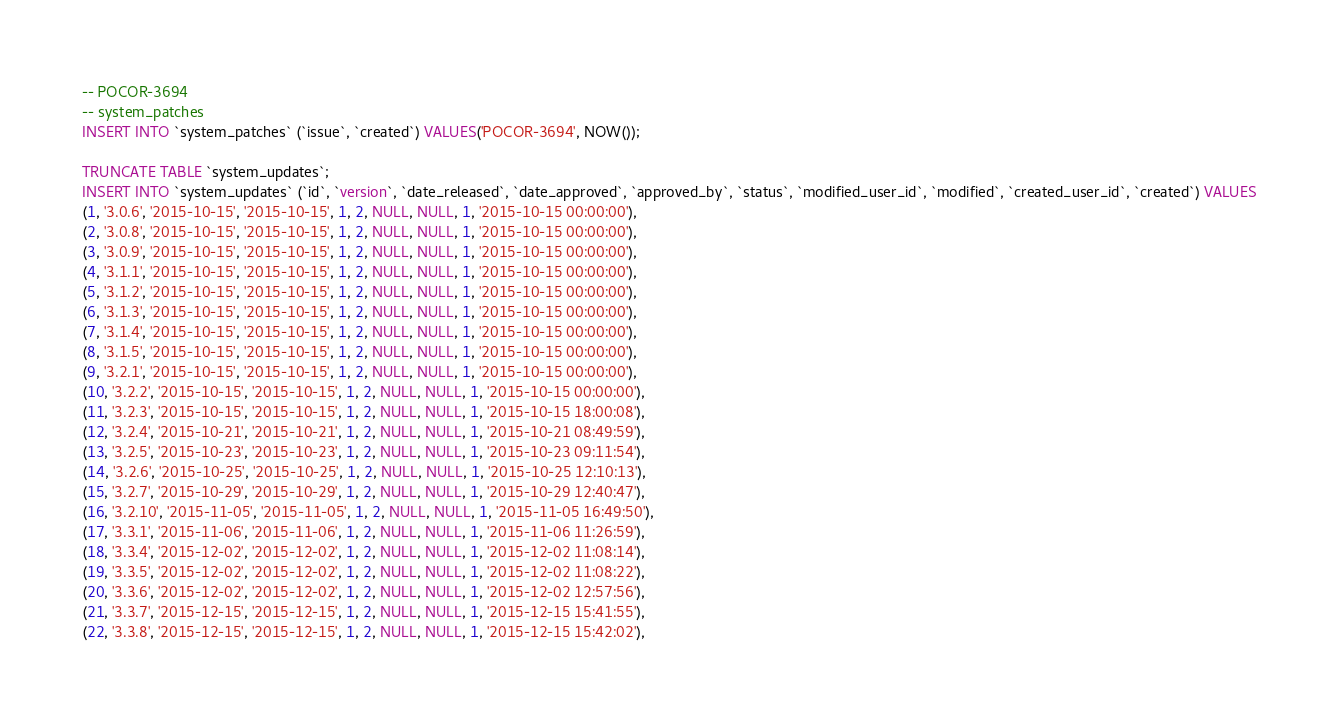<code> <loc_0><loc_0><loc_500><loc_500><_SQL_>-- POCOR-3694
-- system_patches
INSERT INTO `system_patches` (`issue`, `created`) VALUES('POCOR-3694', NOW());

TRUNCATE TABLE `system_updates`;
INSERT INTO `system_updates` (`id`, `version`, `date_released`, `date_approved`, `approved_by`, `status`, `modified_user_id`, `modified`, `created_user_id`, `created`) VALUES
(1, '3.0.6', '2015-10-15', '2015-10-15', 1, 2, NULL, NULL, 1, '2015-10-15 00:00:00'),
(2, '3.0.8', '2015-10-15', '2015-10-15', 1, 2, NULL, NULL, 1, '2015-10-15 00:00:00'),
(3, '3.0.9', '2015-10-15', '2015-10-15', 1, 2, NULL, NULL, 1, '2015-10-15 00:00:00'),
(4, '3.1.1', '2015-10-15', '2015-10-15', 1, 2, NULL, NULL, 1, '2015-10-15 00:00:00'),
(5, '3.1.2', '2015-10-15', '2015-10-15', 1, 2, NULL, NULL, 1, '2015-10-15 00:00:00'),
(6, '3.1.3', '2015-10-15', '2015-10-15', 1, 2, NULL, NULL, 1, '2015-10-15 00:00:00'),
(7, '3.1.4', '2015-10-15', '2015-10-15', 1, 2, NULL, NULL, 1, '2015-10-15 00:00:00'),
(8, '3.1.5', '2015-10-15', '2015-10-15', 1, 2, NULL, NULL, 1, '2015-10-15 00:00:00'),
(9, '3.2.1', '2015-10-15', '2015-10-15', 1, 2, NULL, NULL, 1, '2015-10-15 00:00:00'),
(10, '3.2.2', '2015-10-15', '2015-10-15', 1, 2, NULL, NULL, 1, '2015-10-15 00:00:00'),
(11, '3.2.3', '2015-10-15', '2015-10-15', 1, 2, NULL, NULL, 1, '2015-10-15 18:00:08'),
(12, '3.2.4', '2015-10-21', '2015-10-21', 1, 2, NULL, NULL, 1, '2015-10-21 08:49:59'),
(13, '3.2.5', '2015-10-23', '2015-10-23', 1, 2, NULL, NULL, 1, '2015-10-23 09:11:54'),
(14, '3.2.6', '2015-10-25', '2015-10-25', 1, 2, NULL, NULL, 1, '2015-10-25 12:10:13'),
(15, '3.2.7', '2015-10-29', '2015-10-29', 1, 2, NULL, NULL, 1, '2015-10-29 12:40:47'),
(16, '3.2.10', '2015-11-05', '2015-11-05', 1, 2, NULL, NULL, 1, '2015-11-05 16:49:50'),
(17, '3.3.1', '2015-11-06', '2015-11-06', 1, 2, NULL, NULL, 1, '2015-11-06 11:26:59'),
(18, '3.3.4', '2015-12-02', '2015-12-02', 1, 2, NULL, NULL, 1, '2015-12-02 11:08:14'),
(19, '3.3.5', '2015-12-02', '2015-12-02', 1, 2, NULL, NULL, 1, '2015-12-02 11:08:22'),
(20, '3.3.6', '2015-12-02', '2015-12-02', 1, 2, NULL, NULL, 1, '2015-12-02 12:57:56'),
(21, '3.3.7', '2015-12-15', '2015-12-15', 1, 2, NULL, NULL, 1, '2015-12-15 15:41:55'),
(22, '3.3.8', '2015-12-15', '2015-12-15', 1, 2, NULL, NULL, 1, '2015-12-15 15:42:02'),</code> 